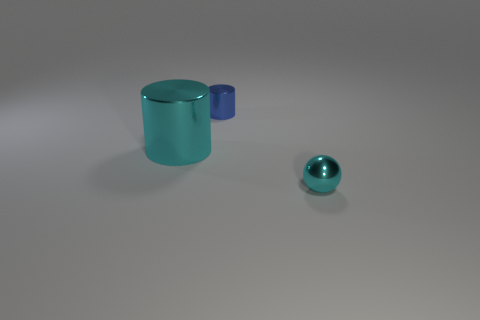Subtract all blue cylinders. Subtract all gray cubes. How many cylinders are left? 1 Add 2 small gray cylinders. How many objects exist? 5 Subtract all spheres. How many objects are left? 2 Add 2 large cylinders. How many large cylinders exist? 3 Subtract 1 blue cylinders. How many objects are left? 2 Subtract all purple matte things. Subtract all tiny cyan metal balls. How many objects are left? 2 Add 3 big cyan cylinders. How many big cyan cylinders are left? 4 